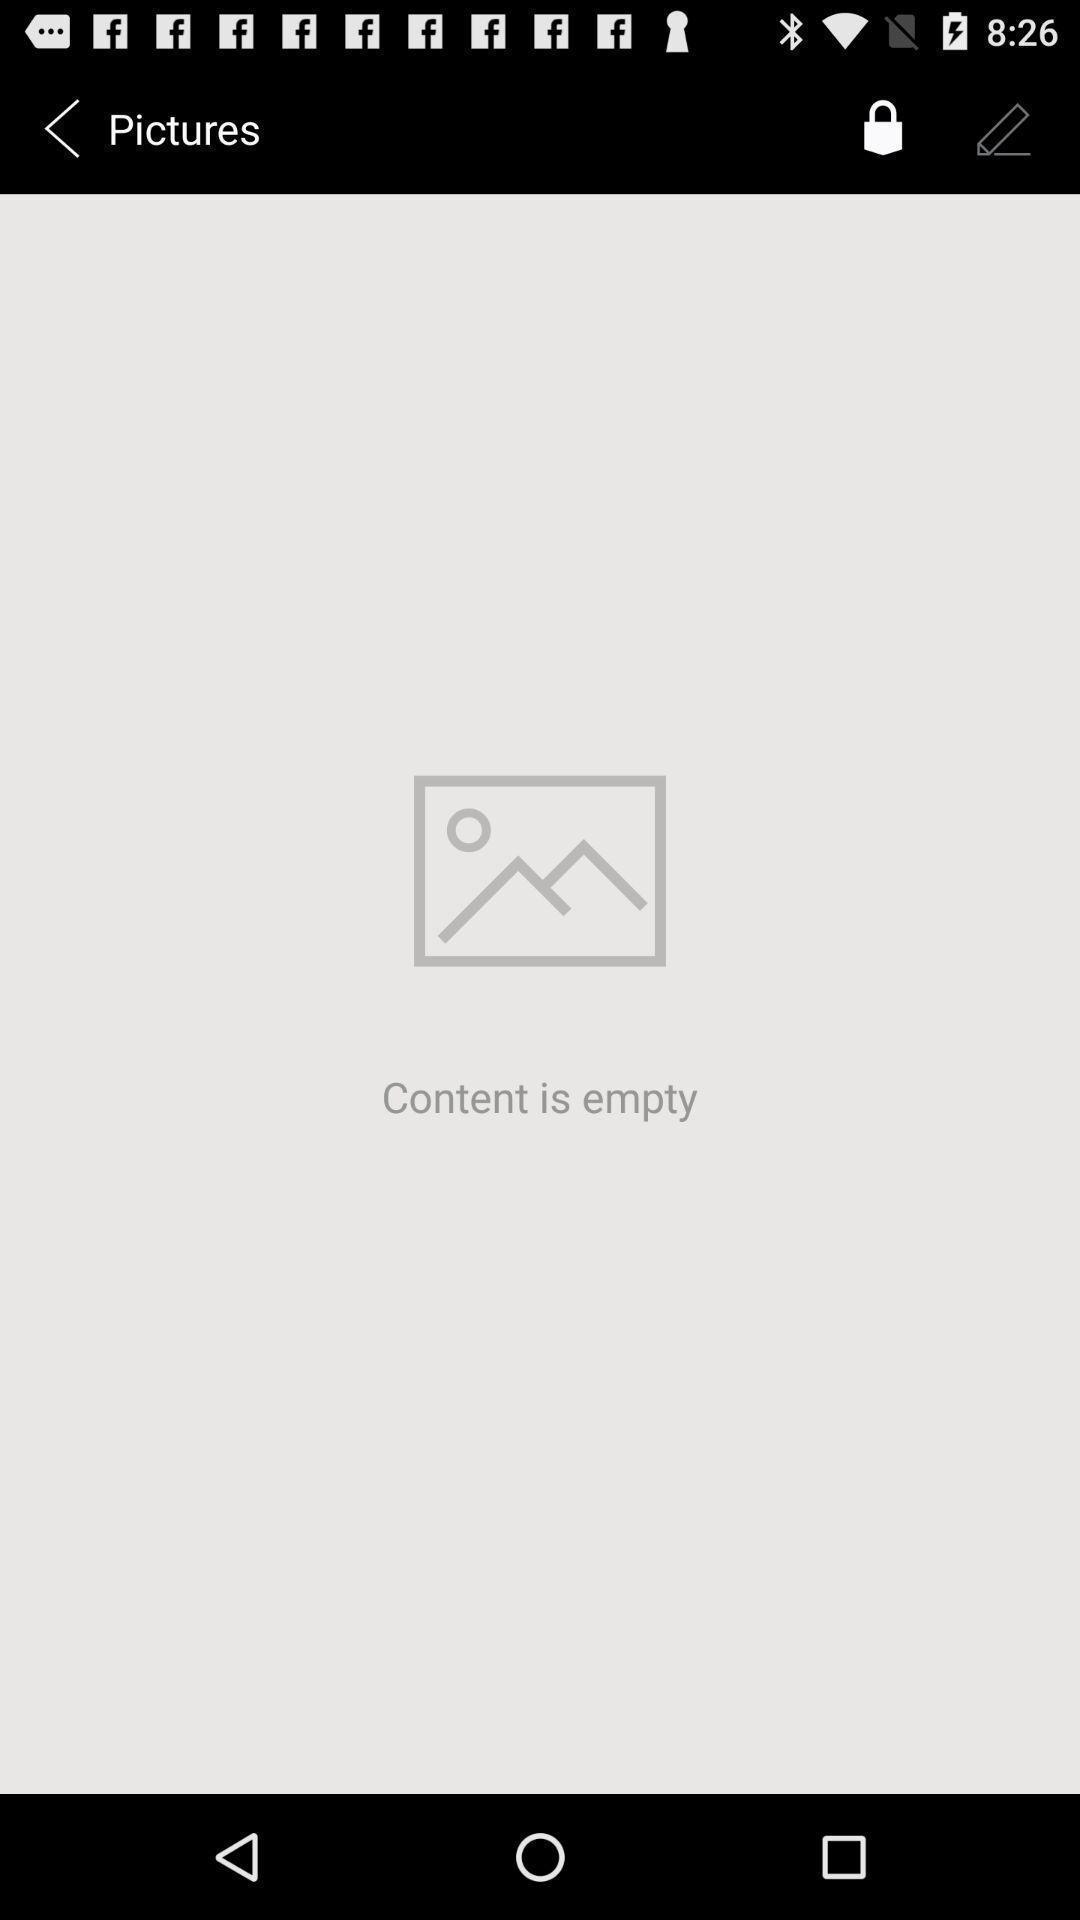Give me a narrative description of this picture. Screen display pictures page. 